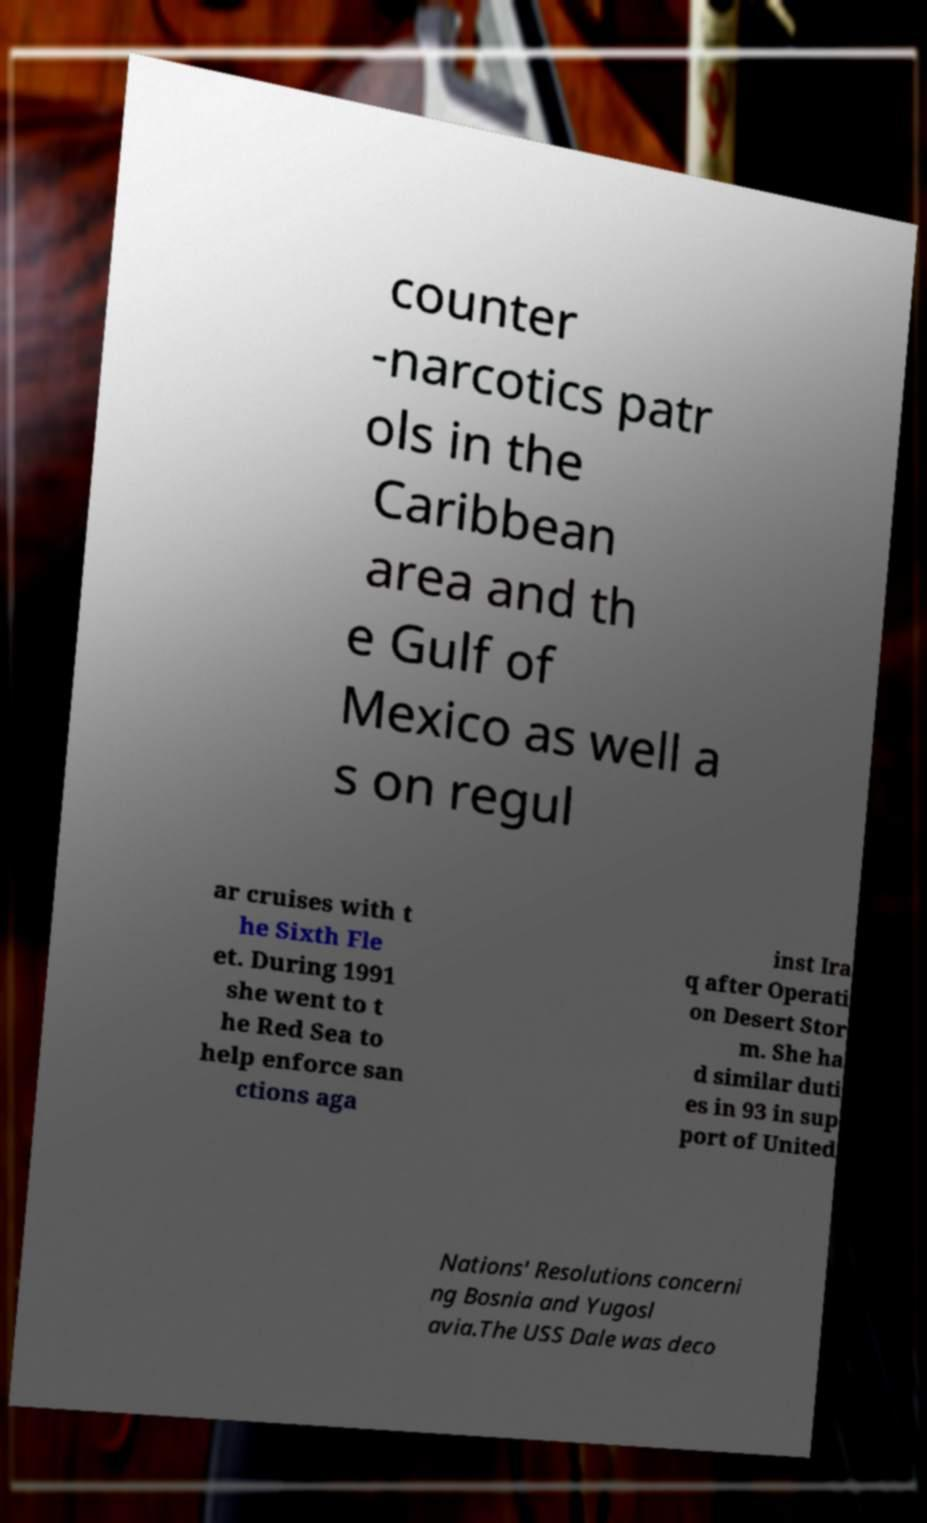What messages or text are displayed in this image? I need them in a readable, typed format. counter -narcotics patr ols in the Caribbean area and th e Gulf of Mexico as well a s on regul ar cruises with t he Sixth Fle et. During 1991 she went to t he Red Sea to help enforce san ctions aga inst Ira q after Operati on Desert Stor m. She ha d similar duti es in 93 in sup port of United Nations' Resolutions concerni ng Bosnia and Yugosl avia.The USS Dale was deco 